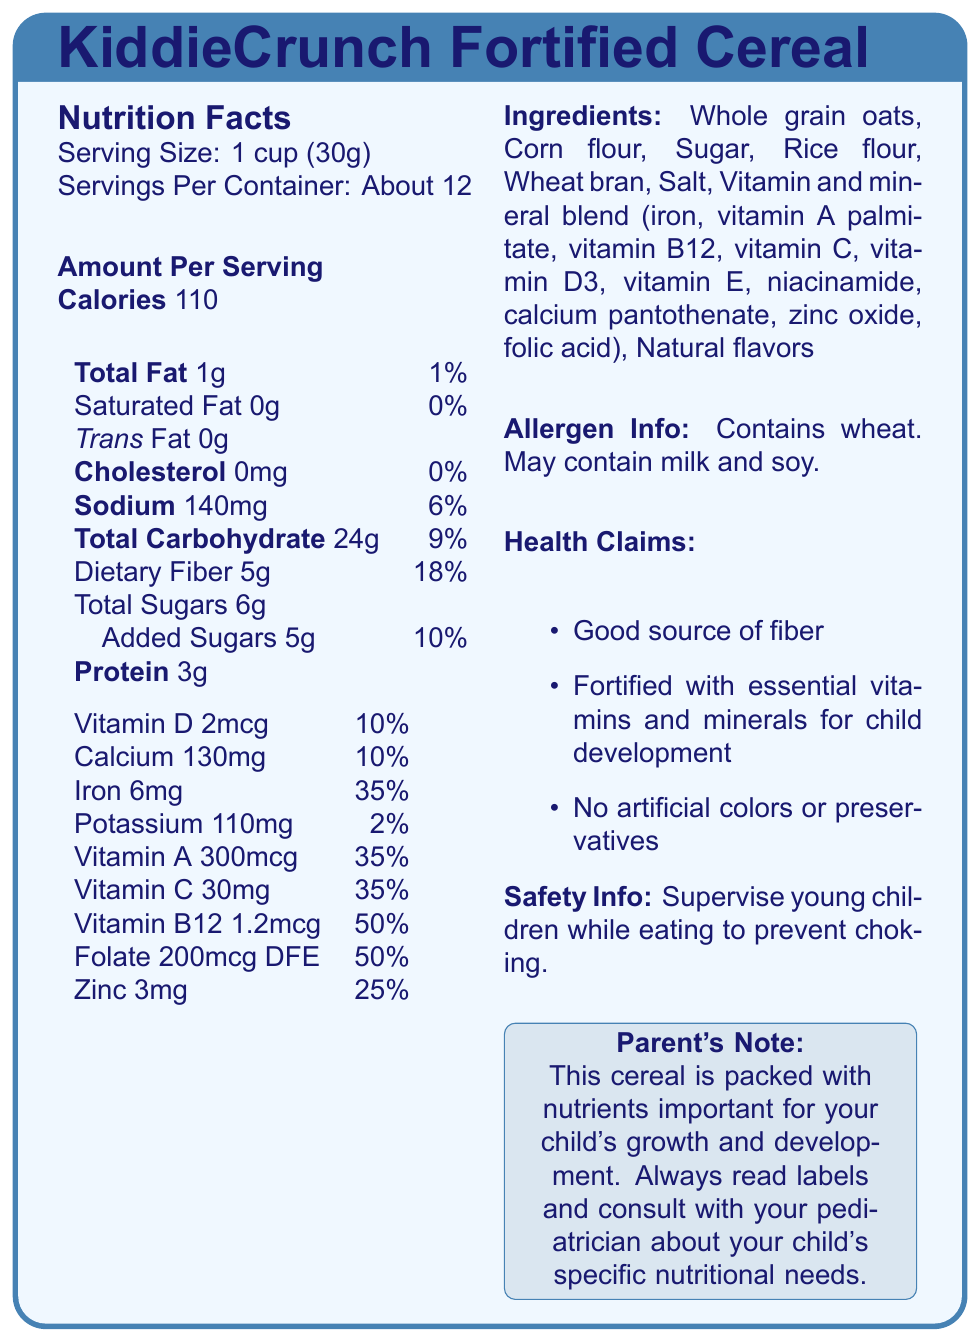What is the serving size for KiddieCrunch Fortified Cereal? The serving size is mentioned at the top of the nutrition facts section: "Serving Size: 1 cup (30g)".
Answer: 1 cup (30g) How much dietary fiber does one serving contain? The dietary fiber content is listed under the "Total Carbohydrate" section as "Dietary Fiber 5g".
Answer: 5g What percentage of the daily value of iron does one serving provide? The iron content is listed with its daily value percentage under the vitamins and minerals section: "Iron 6mg & 35%".
Answer: 35% What is the total carbohydrate content per serving? The total carbohydrate content per serving is listed as "Total Carbohydrate 24g".
Answer: 24g Is this cereal a good source of vitamin B12? The label mentions that the cereal provides 50% of the daily value of vitamin B12, which is typically considered a good source.
Answer: Yes Does this cereal contain any trans fat? The trans fat content is listed as 0g under the "Total Fat" section.
Answer: No Which of the following vitamins are provided at 35% of the daily value? A. Vitamin D B. Vitamin C C. Vitamin A D. Vitamin B12 Both Vitamin A and Vitamin C are listed as providing 35% of the daily value.
Answer: B, C What are the main ingredients in KiddieCrunch Fortified Cereal? A. Whole grain oats, Corn flour, Sugar B. Rice flour, Wheat bran, Salt C. Natural flavors, Vitamin and mineral blend The ingredients include "Whole grain oats, Corn flour, Sugar" as well as "Rice flour, Wheat bran, Salt".
Answer: A, B Is there any mention of artificial colors or preservatives in the ingredients list? The health claims section explicitly states "No artificial colors or preservatives".
Answer: No Summarize the main purpose of the document. The document is a detailed nutrition facts label that includes a list of contents, their amounts, and their percentage of daily value, highlighting key nutrients essential for child development.
Answer: The document provides nutritional information, ingredients, allergen details, and health claims for KiddieCrunch Fortified Cereal. Is the cereal fortified with essential vitamins and minerals? One of the health claims mentions, "Fortified with essential vitamins and minerals for child development".
Answer: Yes What is the daily value percentage of dietary fiber in a serving? The dietary fiber daily value percentage is listed as 18% under the "Total Carbohydrate" section.
Answer: 18% How much calcium does one serving of the cereal contain? The calcium content is listed as "Calcium 130mg" under the vitamins and minerals section.
Answer: 130mg Can you determine if the cereal is gluten-free from the information provided? The document states that the cereal contains wheat, but it doesn't confirm if it's free from all gluten-containing ingredients or processed separately.
Answer: No Is there any information regarding potential allergens in the cereal? The allergen info section states: "Contains wheat. May contain milk and soy".
Answer: Yes 